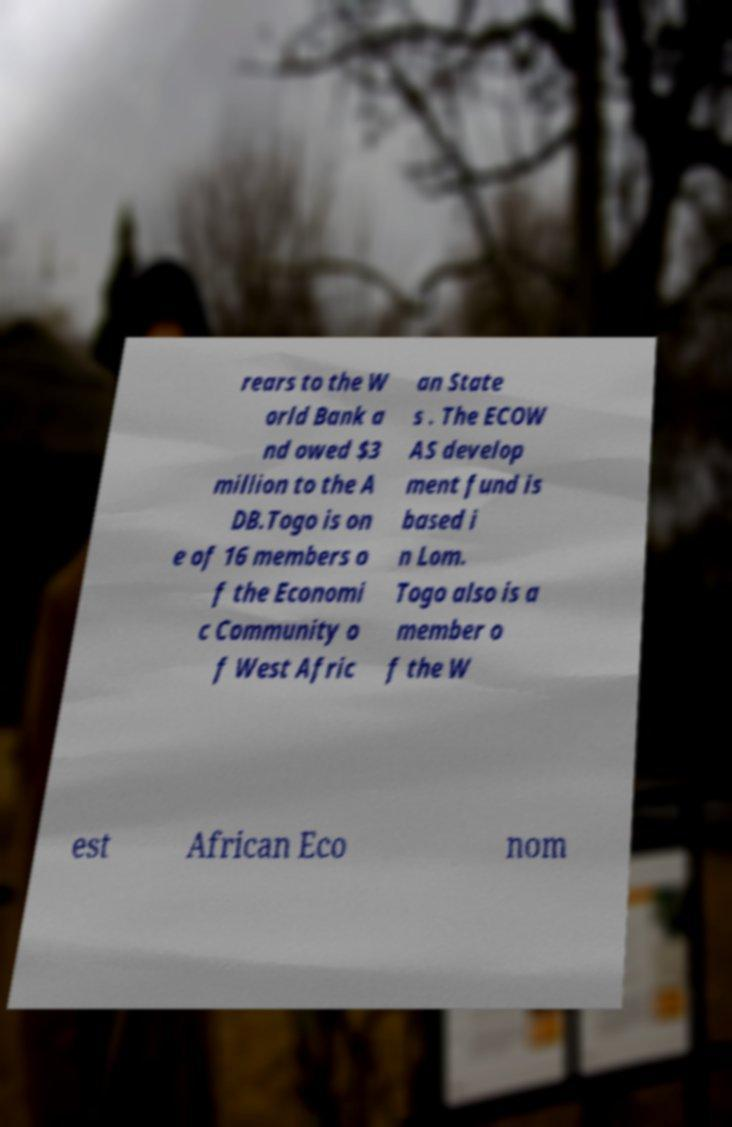For documentation purposes, I need the text within this image transcribed. Could you provide that? rears to the W orld Bank a nd owed $3 million to the A DB.Togo is on e of 16 members o f the Economi c Community o f West Afric an State s . The ECOW AS develop ment fund is based i n Lom. Togo also is a member o f the W est African Eco nom 